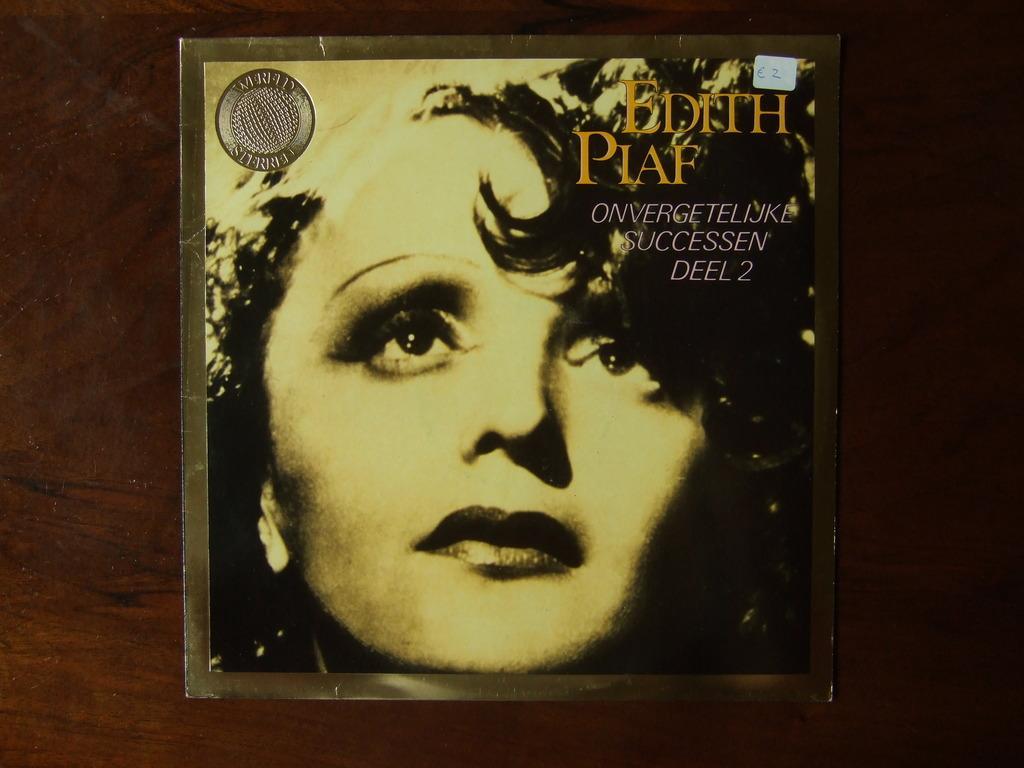Could you give a brief overview of what you see in this image? In this image in the center there is a poster, and on the poster there are some texts and there is the face of the person, and the poster is on the brown colour surface. 